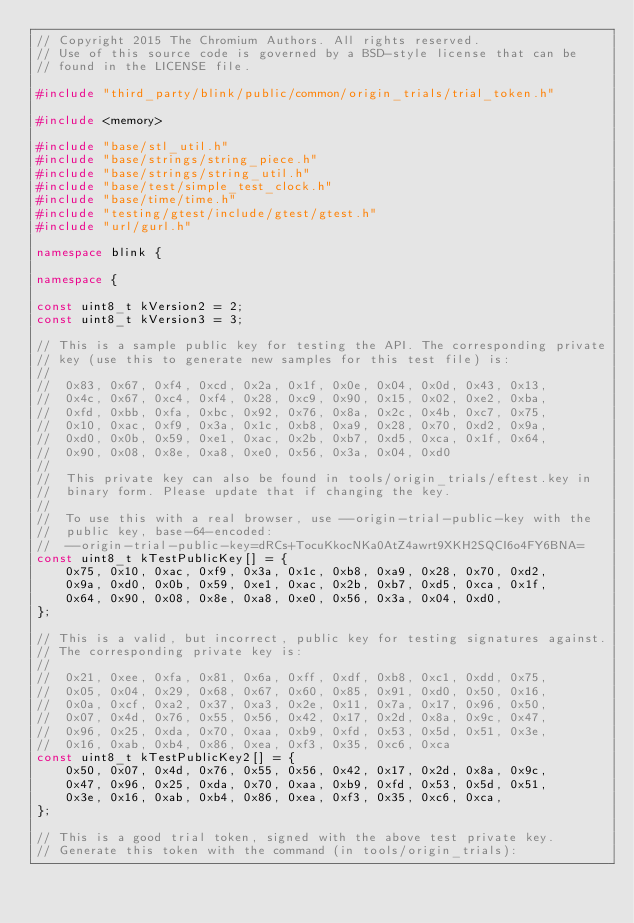Convert code to text. <code><loc_0><loc_0><loc_500><loc_500><_C++_>// Copyright 2015 The Chromium Authors. All rights reserved.
// Use of this source code is governed by a BSD-style license that can be
// found in the LICENSE file.

#include "third_party/blink/public/common/origin_trials/trial_token.h"

#include <memory>

#include "base/stl_util.h"
#include "base/strings/string_piece.h"
#include "base/strings/string_util.h"
#include "base/test/simple_test_clock.h"
#include "base/time/time.h"
#include "testing/gtest/include/gtest/gtest.h"
#include "url/gurl.h"

namespace blink {

namespace {

const uint8_t kVersion2 = 2;
const uint8_t kVersion3 = 3;

// This is a sample public key for testing the API. The corresponding private
// key (use this to generate new samples for this test file) is:
//
//  0x83, 0x67, 0xf4, 0xcd, 0x2a, 0x1f, 0x0e, 0x04, 0x0d, 0x43, 0x13,
//  0x4c, 0x67, 0xc4, 0xf4, 0x28, 0xc9, 0x90, 0x15, 0x02, 0xe2, 0xba,
//  0xfd, 0xbb, 0xfa, 0xbc, 0x92, 0x76, 0x8a, 0x2c, 0x4b, 0xc7, 0x75,
//  0x10, 0xac, 0xf9, 0x3a, 0x1c, 0xb8, 0xa9, 0x28, 0x70, 0xd2, 0x9a,
//  0xd0, 0x0b, 0x59, 0xe1, 0xac, 0x2b, 0xb7, 0xd5, 0xca, 0x1f, 0x64,
//  0x90, 0x08, 0x8e, 0xa8, 0xe0, 0x56, 0x3a, 0x04, 0xd0
//
//  This private key can also be found in tools/origin_trials/eftest.key in
//  binary form. Please update that if changing the key.
//
//  To use this with a real browser, use --origin-trial-public-key with the
//  public key, base-64-encoded:
//  --origin-trial-public-key=dRCs+TocuKkocNKa0AtZ4awrt9XKH2SQCI6o4FY6BNA=
const uint8_t kTestPublicKey[] = {
    0x75, 0x10, 0xac, 0xf9, 0x3a, 0x1c, 0xb8, 0xa9, 0x28, 0x70, 0xd2,
    0x9a, 0xd0, 0x0b, 0x59, 0xe1, 0xac, 0x2b, 0xb7, 0xd5, 0xca, 0x1f,
    0x64, 0x90, 0x08, 0x8e, 0xa8, 0xe0, 0x56, 0x3a, 0x04, 0xd0,
};

// This is a valid, but incorrect, public key for testing signatures against.
// The corresponding private key is:
//
//  0x21, 0xee, 0xfa, 0x81, 0x6a, 0xff, 0xdf, 0xb8, 0xc1, 0xdd, 0x75,
//  0x05, 0x04, 0x29, 0x68, 0x67, 0x60, 0x85, 0x91, 0xd0, 0x50, 0x16,
//  0x0a, 0xcf, 0xa2, 0x37, 0xa3, 0x2e, 0x11, 0x7a, 0x17, 0x96, 0x50,
//  0x07, 0x4d, 0x76, 0x55, 0x56, 0x42, 0x17, 0x2d, 0x8a, 0x9c, 0x47,
//  0x96, 0x25, 0xda, 0x70, 0xaa, 0xb9, 0xfd, 0x53, 0x5d, 0x51, 0x3e,
//  0x16, 0xab, 0xb4, 0x86, 0xea, 0xf3, 0x35, 0xc6, 0xca
const uint8_t kTestPublicKey2[] = {
    0x50, 0x07, 0x4d, 0x76, 0x55, 0x56, 0x42, 0x17, 0x2d, 0x8a, 0x9c,
    0x47, 0x96, 0x25, 0xda, 0x70, 0xaa, 0xb9, 0xfd, 0x53, 0x5d, 0x51,
    0x3e, 0x16, 0xab, 0xb4, 0x86, 0xea, 0xf3, 0x35, 0xc6, 0xca,
};

// This is a good trial token, signed with the above test private key.
// Generate this token with the command (in tools/origin_trials):</code> 